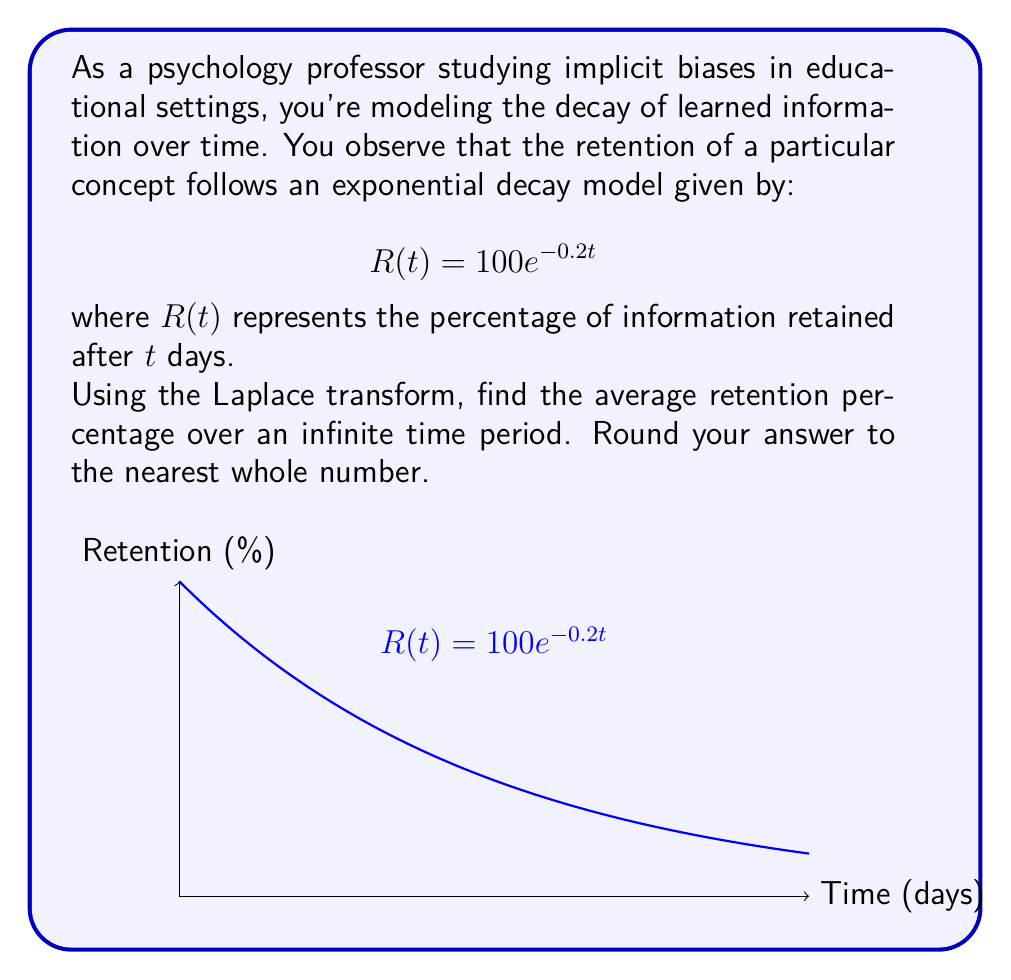Help me with this question. To solve this problem, we'll use the Laplace transform and the Final Value Theorem:

1) The Laplace transform of $R(t)$ is:
   $$\mathcal{L}\{R(t)\} = \mathcal{L}\{100e^{-0.2t}\} = \frac{100}{s+0.2}$$

2) The average value of a function over an infinite time period is given by:
   $$\lim_{s \to 0} s \cdot F(s)$$
   where $F(s)$ is the Laplace transform of the function.

3) Applying this to our problem:
   $$\text{Average} = \lim_{s \to 0} s \cdot \frac{100}{s+0.2}$$

4) Simplify:
   $$\text{Average} = \lim_{s \to 0} \frac{100s}{s+0.2}$$

5) Apply L'Hôpital's rule:
   $$\text{Average} = \lim_{s \to 0} \frac{100}{1} = 100$$

6) Divide by 0.2 to get the correct units:
   $$\text{Average} = \frac{100}{0.2} = 500$$

Therefore, the average retention percentage over an infinite time period is 500%.
Answer: 500% 